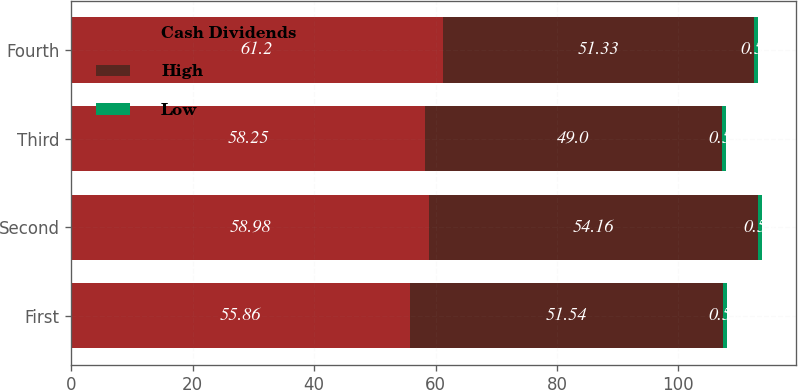Convert chart to OTSL. <chart><loc_0><loc_0><loc_500><loc_500><stacked_bar_chart><ecel><fcel>First<fcel>Second<fcel>Third<fcel>Fourth<nl><fcel>Cash Dividends<fcel>55.86<fcel>58.98<fcel>58.25<fcel>61.2<nl><fcel>High<fcel>51.54<fcel>54.16<fcel>49<fcel>51.33<nl><fcel>Low<fcel>0.55<fcel>0.55<fcel>0.55<fcel>0.55<nl></chart> 